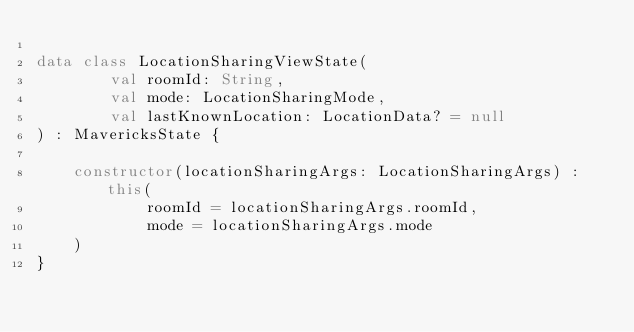Convert code to text. <code><loc_0><loc_0><loc_500><loc_500><_Kotlin_>
data class LocationSharingViewState(
        val roomId: String,
        val mode: LocationSharingMode,
        val lastKnownLocation: LocationData? = null
) : MavericksState {

    constructor(locationSharingArgs: LocationSharingArgs) : this(
            roomId = locationSharingArgs.roomId,
            mode = locationSharingArgs.mode
    )
}
</code> 